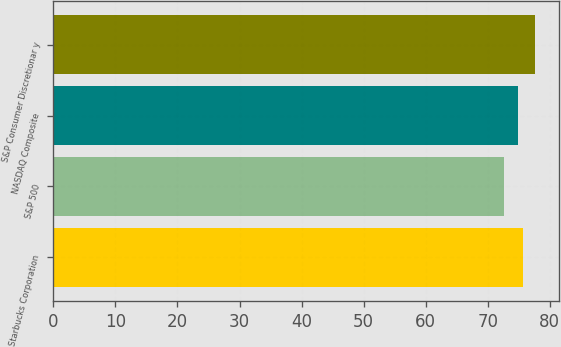Convert chart to OTSL. <chart><loc_0><loc_0><loc_500><loc_500><bar_chart><fcel>Starbucks Corporation<fcel>S&P 500<fcel>NASDAQ Composite<fcel>S&P Consumer Discretionar y<nl><fcel>75.69<fcel>72.63<fcel>74.9<fcel>77.55<nl></chart> 